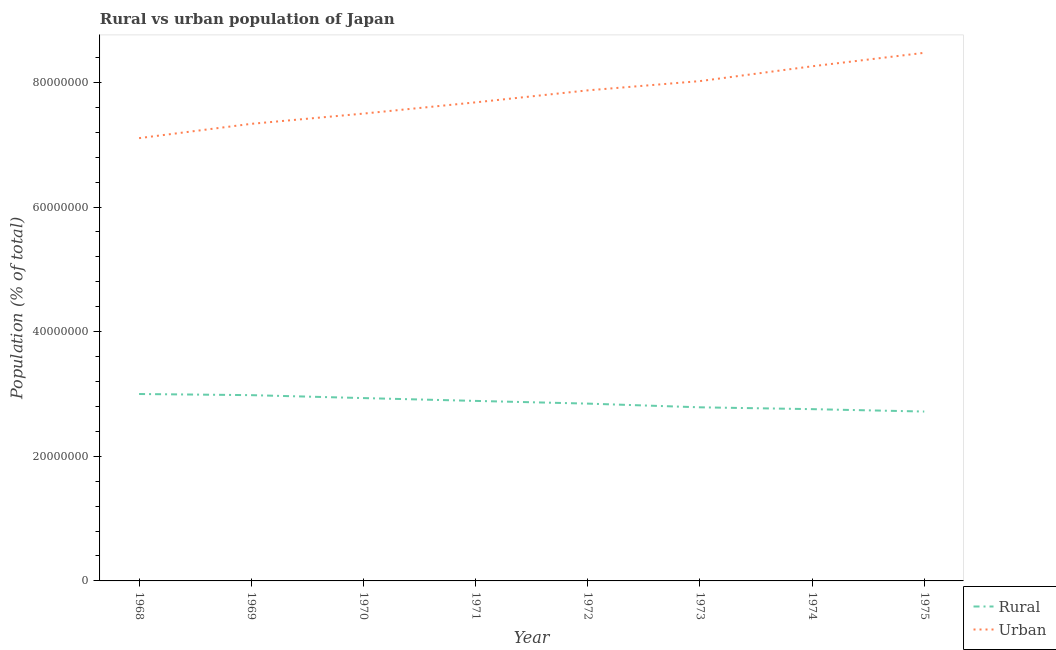Does the line corresponding to urban population density intersect with the line corresponding to rural population density?
Provide a succinct answer. No. What is the rural population density in 1971?
Give a very brief answer. 2.89e+07. Across all years, what is the maximum urban population density?
Your response must be concise. 8.48e+07. Across all years, what is the minimum urban population density?
Your answer should be very brief. 7.11e+07. In which year was the rural population density maximum?
Your answer should be very brief. 1968. In which year was the rural population density minimum?
Provide a succinct answer. 1975. What is the total rural population density in the graph?
Provide a short and direct response. 2.29e+08. What is the difference between the urban population density in 1973 and that in 1975?
Offer a very short reply. -4.54e+06. What is the difference between the rural population density in 1975 and the urban population density in 1970?
Your answer should be very brief. -4.78e+07. What is the average rural population density per year?
Ensure brevity in your answer.  2.86e+07. In the year 1973, what is the difference between the rural population density and urban population density?
Your answer should be very brief. -5.24e+07. In how many years, is the urban population density greater than 8000000 %?
Offer a very short reply. 8. What is the ratio of the urban population density in 1968 to that in 1975?
Your response must be concise. 0.84. Is the urban population density in 1973 less than that in 1974?
Your answer should be compact. Yes. Is the difference between the urban population density in 1968 and 1969 greater than the difference between the rural population density in 1968 and 1969?
Your response must be concise. No. What is the difference between the highest and the second highest urban population density?
Keep it short and to the point. 2.16e+06. What is the difference between the highest and the lowest rural population density?
Your answer should be compact. 2.82e+06. Is the sum of the rural population density in 1969 and 1971 greater than the maximum urban population density across all years?
Your answer should be very brief. No. Does the urban population density monotonically increase over the years?
Provide a short and direct response. Yes. Are the values on the major ticks of Y-axis written in scientific E-notation?
Make the answer very short. No. Does the graph contain any zero values?
Ensure brevity in your answer.  No. Where does the legend appear in the graph?
Give a very brief answer. Bottom right. How many legend labels are there?
Give a very brief answer. 2. What is the title of the graph?
Your response must be concise. Rural vs urban population of Japan. Does "% of GNI" appear as one of the legend labels in the graph?
Your answer should be compact. No. What is the label or title of the X-axis?
Make the answer very short. Year. What is the label or title of the Y-axis?
Ensure brevity in your answer.  Population (% of total). What is the Population (% of total) in Rural in 1968?
Ensure brevity in your answer.  3.00e+07. What is the Population (% of total) in Urban in 1968?
Make the answer very short. 7.11e+07. What is the Population (% of total) in Rural in 1969?
Your answer should be very brief. 2.98e+07. What is the Population (% of total) of Urban in 1969?
Offer a terse response. 7.34e+07. What is the Population (% of total) of Rural in 1970?
Your answer should be very brief. 2.93e+07. What is the Population (% of total) in Urban in 1970?
Provide a short and direct response. 7.50e+07. What is the Population (% of total) in Rural in 1971?
Provide a succinct answer. 2.89e+07. What is the Population (% of total) in Urban in 1971?
Give a very brief answer. 7.68e+07. What is the Population (% of total) of Rural in 1972?
Your answer should be very brief. 2.85e+07. What is the Population (% of total) of Urban in 1972?
Offer a terse response. 7.87e+07. What is the Population (% of total) in Rural in 1973?
Your answer should be compact. 2.79e+07. What is the Population (% of total) in Urban in 1973?
Make the answer very short. 8.02e+07. What is the Population (% of total) of Rural in 1974?
Offer a very short reply. 2.76e+07. What is the Population (% of total) in Urban in 1974?
Keep it short and to the point. 8.26e+07. What is the Population (% of total) in Rural in 1975?
Offer a very short reply. 2.72e+07. What is the Population (% of total) in Urban in 1975?
Make the answer very short. 8.48e+07. Across all years, what is the maximum Population (% of total) of Rural?
Keep it short and to the point. 3.00e+07. Across all years, what is the maximum Population (% of total) in Urban?
Make the answer very short. 8.48e+07. Across all years, what is the minimum Population (% of total) of Rural?
Offer a very short reply. 2.72e+07. Across all years, what is the minimum Population (% of total) of Urban?
Ensure brevity in your answer.  7.11e+07. What is the total Population (% of total) of Rural in the graph?
Provide a succinct answer. 2.29e+08. What is the total Population (% of total) in Urban in the graph?
Make the answer very short. 6.23e+08. What is the difference between the Population (% of total) in Rural in 1968 and that in 1969?
Your answer should be very brief. 1.84e+05. What is the difference between the Population (% of total) in Urban in 1968 and that in 1969?
Provide a short and direct response. -2.30e+06. What is the difference between the Population (% of total) in Rural in 1968 and that in 1970?
Offer a very short reply. 6.54e+05. What is the difference between the Population (% of total) in Urban in 1968 and that in 1970?
Your response must be concise. -3.94e+06. What is the difference between the Population (% of total) in Rural in 1968 and that in 1971?
Ensure brevity in your answer.  1.11e+06. What is the difference between the Population (% of total) of Urban in 1968 and that in 1971?
Offer a very short reply. -5.74e+06. What is the difference between the Population (% of total) in Rural in 1968 and that in 1972?
Your response must be concise. 1.54e+06. What is the difference between the Population (% of total) in Urban in 1968 and that in 1972?
Offer a very short reply. -7.67e+06. What is the difference between the Population (% of total) in Rural in 1968 and that in 1973?
Provide a short and direct response. 2.14e+06. What is the difference between the Population (% of total) of Urban in 1968 and that in 1973?
Your answer should be very brief. -9.15e+06. What is the difference between the Population (% of total) of Rural in 1968 and that in 1974?
Offer a terse response. 2.43e+06. What is the difference between the Population (% of total) in Urban in 1968 and that in 1974?
Provide a short and direct response. -1.15e+07. What is the difference between the Population (% of total) of Rural in 1968 and that in 1975?
Provide a succinct answer. 2.82e+06. What is the difference between the Population (% of total) in Urban in 1968 and that in 1975?
Offer a very short reply. -1.37e+07. What is the difference between the Population (% of total) in Rural in 1969 and that in 1970?
Give a very brief answer. 4.70e+05. What is the difference between the Population (% of total) in Urban in 1969 and that in 1970?
Ensure brevity in your answer.  -1.64e+06. What is the difference between the Population (% of total) in Rural in 1969 and that in 1971?
Offer a very short reply. 9.23e+05. What is the difference between the Population (% of total) of Urban in 1969 and that in 1971?
Ensure brevity in your answer.  -3.45e+06. What is the difference between the Population (% of total) in Rural in 1969 and that in 1972?
Offer a very short reply. 1.36e+06. What is the difference between the Population (% of total) of Urban in 1969 and that in 1972?
Offer a very short reply. -5.37e+06. What is the difference between the Population (% of total) in Rural in 1969 and that in 1973?
Make the answer very short. 1.95e+06. What is the difference between the Population (% of total) of Urban in 1969 and that in 1973?
Your answer should be very brief. -6.86e+06. What is the difference between the Population (% of total) in Rural in 1969 and that in 1974?
Ensure brevity in your answer.  2.25e+06. What is the difference between the Population (% of total) in Urban in 1969 and that in 1974?
Offer a very short reply. -9.24e+06. What is the difference between the Population (% of total) in Rural in 1969 and that in 1975?
Your response must be concise. 2.63e+06. What is the difference between the Population (% of total) in Urban in 1969 and that in 1975?
Make the answer very short. -1.14e+07. What is the difference between the Population (% of total) in Rural in 1970 and that in 1971?
Keep it short and to the point. 4.54e+05. What is the difference between the Population (% of total) of Urban in 1970 and that in 1971?
Your answer should be very brief. -1.81e+06. What is the difference between the Population (% of total) of Rural in 1970 and that in 1972?
Ensure brevity in your answer.  8.89e+05. What is the difference between the Population (% of total) of Urban in 1970 and that in 1972?
Ensure brevity in your answer.  -3.73e+06. What is the difference between the Population (% of total) in Rural in 1970 and that in 1973?
Ensure brevity in your answer.  1.48e+06. What is the difference between the Population (% of total) of Urban in 1970 and that in 1973?
Make the answer very short. -5.22e+06. What is the difference between the Population (% of total) in Rural in 1970 and that in 1974?
Provide a short and direct response. 1.78e+06. What is the difference between the Population (% of total) of Urban in 1970 and that in 1974?
Make the answer very short. -7.59e+06. What is the difference between the Population (% of total) of Rural in 1970 and that in 1975?
Provide a succinct answer. 2.16e+06. What is the difference between the Population (% of total) in Urban in 1970 and that in 1975?
Your response must be concise. -9.76e+06. What is the difference between the Population (% of total) of Rural in 1971 and that in 1972?
Provide a succinct answer. 4.35e+05. What is the difference between the Population (% of total) in Urban in 1971 and that in 1972?
Provide a short and direct response. -1.93e+06. What is the difference between the Population (% of total) of Rural in 1971 and that in 1973?
Provide a succinct answer. 1.03e+06. What is the difference between the Population (% of total) in Urban in 1971 and that in 1973?
Your answer should be compact. -3.41e+06. What is the difference between the Population (% of total) of Rural in 1971 and that in 1974?
Provide a succinct answer. 1.32e+06. What is the difference between the Population (% of total) in Urban in 1971 and that in 1974?
Give a very brief answer. -5.79e+06. What is the difference between the Population (% of total) of Rural in 1971 and that in 1975?
Offer a terse response. 1.71e+06. What is the difference between the Population (% of total) of Urban in 1971 and that in 1975?
Provide a succinct answer. -7.95e+06. What is the difference between the Population (% of total) in Rural in 1972 and that in 1973?
Your answer should be compact. 5.94e+05. What is the difference between the Population (% of total) of Urban in 1972 and that in 1973?
Offer a very short reply. -1.48e+06. What is the difference between the Population (% of total) in Rural in 1972 and that in 1974?
Offer a very short reply. 8.88e+05. What is the difference between the Population (% of total) in Urban in 1972 and that in 1974?
Offer a very short reply. -3.86e+06. What is the difference between the Population (% of total) of Rural in 1972 and that in 1975?
Keep it short and to the point. 1.27e+06. What is the difference between the Population (% of total) of Urban in 1972 and that in 1975?
Keep it short and to the point. -6.02e+06. What is the difference between the Population (% of total) of Rural in 1973 and that in 1974?
Offer a very short reply. 2.95e+05. What is the difference between the Population (% of total) in Urban in 1973 and that in 1974?
Provide a short and direct response. -2.38e+06. What is the difference between the Population (% of total) of Rural in 1973 and that in 1975?
Provide a short and direct response. 6.79e+05. What is the difference between the Population (% of total) of Urban in 1973 and that in 1975?
Your answer should be compact. -4.54e+06. What is the difference between the Population (% of total) of Rural in 1974 and that in 1975?
Your answer should be compact. 3.85e+05. What is the difference between the Population (% of total) of Urban in 1974 and that in 1975?
Provide a short and direct response. -2.16e+06. What is the difference between the Population (% of total) of Rural in 1968 and the Population (% of total) of Urban in 1969?
Make the answer very short. -4.34e+07. What is the difference between the Population (% of total) in Rural in 1968 and the Population (% of total) in Urban in 1970?
Make the answer very short. -4.50e+07. What is the difference between the Population (% of total) in Rural in 1968 and the Population (% of total) in Urban in 1971?
Offer a terse response. -4.68e+07. What is the difference between the Population (% of total) of Rural in 1968 and the Population (% of total) of Urban in 1972?
Offer a terse response. -4.87e+07. What is the difference between the Population (% of total) of Rural in 1968 and the Population (% of total) of Urban in 1973?
Make the answer very short. -5.02e+07. What is the difference between the Population (% of total) in Rural in 1968 and the Population (% of total) in Urban in 1974?
Keep it short and to the point. -5.26e+07. What is the difference between the Population (% of total) of Rural in 1968 and the Population (% of total) of Urban in 1975?
Your answer should be compact. -5.48e+07. What is the difference between the Population (% of total) of Rural in 1969 and the Population (% of total) of Urban in 1970?
Offer a terse response. -4.52e+07. What is the difference between the Population (% of total) of Rural in 1969 and the Population (% of total) of Urban in 1971?
Make the answer very short. -4.70e+07. What is the difference between the Population (% of total) in Rural in 1969 and the Population (% of total) in Urban in 1972?
Provide a succinct answer. -4.89e+07. What is the difference between the Population (% of total) in Rural in 1969 and the Population (% of total) in Urban in 1973?
Provide a short and direct response. -5.04e+07. What is the difference between the Population (% of total) of Rural in 1969 and the Population (% of total) of Urban in 1974?
Provide a short and direct response. -5.28e+07. What is the difference between the Population (% of total) in Rural in 1969 and the Population (% of total) in Urban in 1975?
Your response must be concise. -5.49e+07. What is the difference between the Population (% of total) of Rural in 1970 and the Population (% of total) of Urban in 1971?
Provide a succinct answer. -4.75e+07. What is the difference between the Population (% of total) of Rural in 1970 and the Population (% of total) of Urban in 1972?
Your answer should be very brief. -4.94e+07. What is the difference between the Population (% of total) in Rural in 1970 and the Population (% of total) in Urban in 1973?
Give a very brief answer. -5.09e+07. What is the difference between the Population (% of total) of Rural in 1970 and the Population (% of total) of Urban in 1974?
Provide a succinct answer. -5.32e+07. What is the difference between the Population (% of total) of Rural in 1970 and the Population (% of total) of Urban in 1975?
Offer a terse response. -5.54e+07. What is the difference between the Population (% of total) of Rural in 1971 and the Population (% of total) of Urban in 1972?
Your response must be concise. -4.98e+07. What is the difference between the Population (% of total) in Rural in 1971 and the Population (% of total) in Urban in 1973?
Your answer should be compact. -5.13e+07. What is the difference between the Population (% of total) of Rural in 1971 and the Population (% of total) of Urban in 1974?
Ensure brevity in your answer.  -5.37e+07. What is the difference between the Population (% of total) in Rural in 1971 and the Population (% of total) in Urban in 1975?
Offer a very short reply. -5.59e+07. What is the difference between the Population (% of total) of Rural in 1972 and the Population (% of total) of Urban in 1973?
Ensure brevity in your answer.  -5.18e+07. What is the difference between the Population (% of total) in Rural in 1972 and the Population (% of total) in Urban in 1974?
Ensure brevity in your answer.  -5.41e+07. What is the difference between the Population (% of total) of Rural in 1972 and the Population (% of total) of Urban in 1975?
Offer a terse response. -5.63e+07. What is the difference between the Population (% of total) in Rural in 1973 and the Population (% of total) in Urban in 1974?
Your answer should be very brief. -5.47e+07. What is the difference between the Population (% of total) of Rural in 1973 and the Population (% of total) of Urban in 1975?
Offer a very short reply. -5.69e+07. What is the difference between the Population (% of total) in Rural in 1974 and the Population (% of total) in Urban in 1975?
Make the answer very short. -5.72e+07. What is the average Population (% of total) of Rural per year?
Provide a short and direct response. 2.86e+07. What is the average Population (% of total) of Urban per year?
Ensure brevity in your answer.  7.78e+07. In the year 1968, what is the difference between the Population (% of total) in Rural and Population (% of total) in Urban?
Make the answer very short. -4.11e+07. In the year 1969, what is the difference between the Population (% of total) of Rural and Population (% of total) of Urban?
Your answer should be compact. -4.35e+07. In the year 1970, what is the difference between the Population (% of total) in Rural and Population (% of total) in Urban?
Offer a very short reply. -4.57e+07. In the year 1971, what is the difference between the Population (% of total) in Rural and Population (% of total) in Urban?
Ensure brevity in your answer.  -4.79e+07. In the year 1972, what is the difference between the Population (% of total) in Rural and Population (% of total) in Urban?
Ensure brevity in your answer.  -5.03e+07. In the year 1973, what is the difference between the Population (% of total) of Rural and Population (% of total) of Urban?
Your answer should be very brief. -5.24e+07. In the year 1974, what is the difference between the Population (% of total) of Rural and Population (% of total) of Urban?
Your answer should be compact. -5.50e+07. In the year 1975, what is the difference between the Population (% of total) in Rural and Population (% of total) in Urban?
Offer a terse response. -5.76e+07. What is the ratio of the Population (% of total) in Urban in 1968 to that in 1969?
Ensure brevity in your answer.  0.97. What is the ratio of the Population (% of total) in Rural in 1968 to that in 1970?
Offer a very short reply. 1.02. What is the ratio of the Population (% of total) in Urban in 1968 to that in 1970?
Provide a short and direct response. 0.95. What is the ratio of the Population (% of total) of Rural in 1968 to that in 1971?
Ensure brevity in your answer.  1.04. What is the ratio of the Population (% of total) in Urban in 1968 to that in 1971?
Offer a very short reply. 0.93. What is the ratio of the Population (% of total) of Rural in 1968 to that in 1972?
Your answer should be very brief. 1.05. What is the ratio of the Population (% of total) in Urban in 1968 to that in 1972?
Your answer should be very brief. 0.9. What is the ratio of the Population (% of total) of Rural in 1968 to that in 1973?
Offer a terse response. 1.08. What is the ratio of the Population (% of total) of Urban in 1968 to that in 1973?
Provide a short and direct response. 0.89. What is the ratio of the Population (% of total) of Rural in 1968 to that in 1974?
Give a very brief answer. 1.09. What is the ratio of the Population (% of total) of Urban in 1968 to that in 1974?
Your answer should be very brief. 0.86. What is the ratio of the Population (% of total) of Rural in 1968 to that in 1975?
Your answer should be very brief. 1.1. What is the ratio of the Population (% of total) of Urban in 1968 to that in 1975?
Offer a terse response. 0.84. What is the ratio of the Population (% of total) in Urban in 1969 to that in 1970?
Provide a succinct answer. 0.98. What is the ratio of the Population (% of total) in Rural in 1969 to that in 1971?
Your response must be concise. 1.03. What is the ratio of the Population (% of total) in Urban in 1969 to that in 1971?
Keep it short and to the point. 0.96. What is the ratio of the Population (% of total) in Rural in 1969 to that in 1972?
Keep it short and to the point. 1.05. What is the ratio of the Population (% of total) of Urban in 1969 to that in 1972?
Your response must be concise. 0.93. What is the ratio of the Population (% of total) of Rural in 1969 to that in 1973?
Ensure brevity in your answer.  1.07. What is the ratio of the Population (% of total) of Urban in 1969 to that in 1973?
Offer a terse response. 0.91. What is the ratio of the Population (% of total) of Rural in 1969 to that in 1974?
Give a very brief answer. 1.08. What is the ratio of the Population (% of total) in Urban in 1969 to that in 1974?
Offer a very short reply. 0.89. What is the ratio of the Population (% of total) in Rural in 1969 to that in 1975?
Give a very brief answer. 1.1. What is the ratio of the Population (% of total) of Urban in 1969 to that in 1975?
Make the answer very short. 0.87. What is the ratio of the Population (% of total) of Rural in 1970 to that in 1971?
Your response must be concise. 1.02. What is the ratio of the Population (% of total) of Urban in 1970 to that in 1971?
Make the answer very short. 0.98. What is the ratio of the Population (% of total) in Rural in 1970 to that in 1972?
Ensure brevity in your answer.  1.03. What is the ratio of the Population (% of total) of Urban in 1970 to that in 1972?
Ensure brevity in your answer.  0.95. What is the ratio of the Population (% of total) in Rural in 1970 to that in 1973?
Provide a short and direct response. 1.05. What is the ratio of the Population (% of total) of Urban in 1970 to that in 1973?
Your answer should be very brief. 0.94. What is the ratio of the Population (% of total) in Rural in 1970 to that in 1974?
Make the answer very short. 1.06. What is the ratio of the Population (% of total) in Urban in 1970 to that in 1974?
Your response must be concise. 0.91. What is the ratio of the Population (% of total) in Rural in 1970 to that in 1975?
Your answer should be very brief. 1.08. What is the ratio of the Population (% of total) in Urban in 1970 to that in 1975?
Make the answer very short. 0.88. What is the ratio of the Population (% of total) of Rural in 1971 to that in 1972?
Give a very brief answer. 1.02. What is the ratio of the Population (% of total) of Urban in 1971 to that in 1972?
Make the answer very short. 0.98. What is the ratio of the Population (% of total) of Rural in 1971 to that in 1973?
Keep it short and to the point. 1.04. What is the ratio of the Population (% of total) in Urban in 1971 to that in 1973?
Your answer should be compact. 0.96. What is the ratio of the Population (% of total) in Rural in 1971 to that in 1974?
Offer a terse response. 1.05. What is the ratio of the Population (% of total) of Urban in 1971 to that in 1974?
Ensure brevity in your answer.  0.93. What is the ratio of the Population (% of total) in Rural in 1971 to that in 1975?
Provide a succinct answer. 1.06. What is the ratio of the Population (% of total) of Urban in 1971 to that in 1975?
Make the answer very short. 0.91. What is the ratio of the Population (% of total) of Rural in 1972 to that in 1973?
Offer a very short reply. 1.02. What is the ratio of the Population (% of total) of Urban in 1972 to that in 1973?
Provide a short and direct response. 0.98. What is the ratio of the Population (% of total) in Rural in 1972 to that in 1974?
Your answer should be compact. 1.03. What is the ratio of the Population (% of total) in Urban in 1972 to that in 1974?
Provide a short and direct response. 0.95. What is the ratio of the Population (% of total) in Rural in 1972 to that in 1975?
Provide a short and direct response. 1.05. What is the ratio of the Population (% of total) of Urban in 1972 to that in 1975?
Keep it short and to the point. 0.93. What is the ratio of the Population (% of total) of Rural in 1973 to that in 1974?
Provide a short and direct response. 1.01. What is the ratio of the Population (% of total) in Urban in 1973 to that in 1974?
Provide a succinct answer. 0.97. What is the ratio of the Population (% of total) of Urban in 1973 to that in 1975?
Offer a terse response. 0.95. What is the ratio of the Population (% of total) in Rural in 1974 to that in 1975?
Your answer should be very brief. 1.01. What is the ratio of the Population (% of total) in Urban in 1974 to that in 1975?
Keep it short and to the point. 0.97. What is the difference between the highest and the second highest Population (% of total) in Rural?
Provide a succinct answer. 1.84e+05. What is the difference between the highest and the second highest Population (% of total) of Urban?
Ensure brevity in your answer.  2.16e+06. What is the difference between the highest and the lowest Population (% of total) of Rural?
Offer a very short reply. 2.82e+06. What is the difference between the highest and the lowest Population (% of total) in Urban?
Offer a terse response. 1.37e+07. 